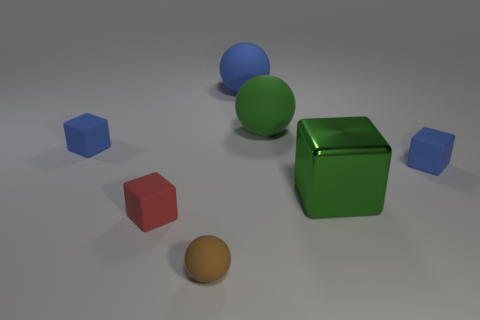Subtract 1 cubes. How many cubes are left? 3 Add 2 metal things. How many objects exist? 9 Subtract all spheres. How many objects are left? 4 Add 2 small cubes. How many small cubes are left? 5 Add 3 tiny matte balls. How many tiny matte balls exist? 4 Subtract 0 brown cubes. How many objects are left? 7 Subtract all tiny blue matte blocks. Subtract all brown objects. How many objects are left? 4 